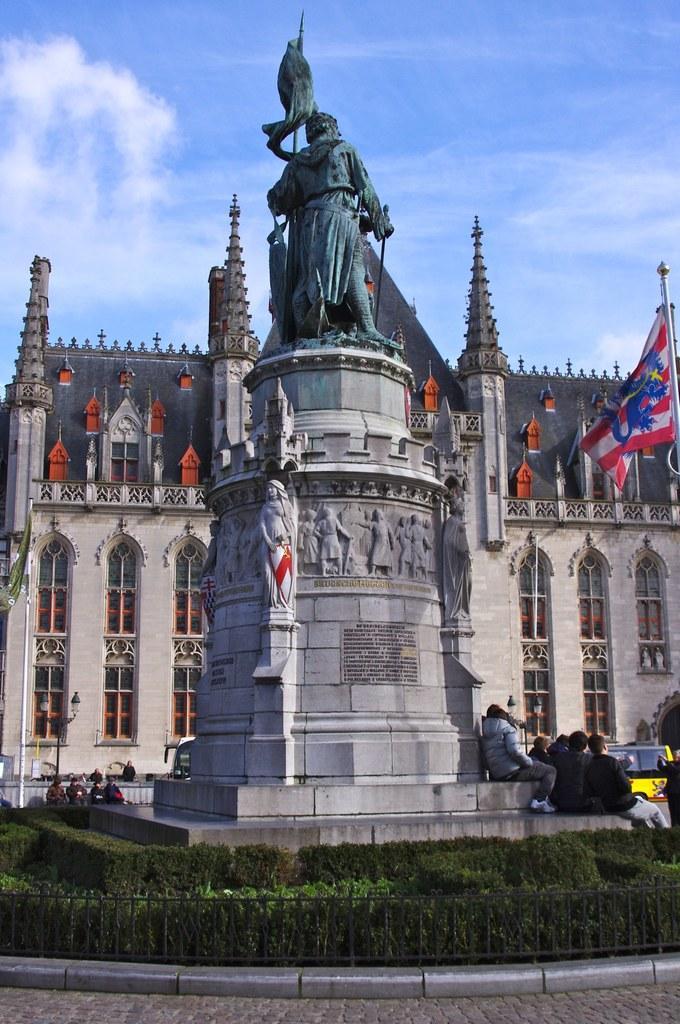Could you give a brief overview of what you see in this image? In front of the picture, we see a monument or a statue of the man standing. At the bottom of the picture, we see plants, shrubs and a railing. We see people sitting beside the monument. Beside them, we see a yellow color vehicle is moving on the road. In the background, we see a building and it looks like a court. On the right side, we see a flag in red, white and blue color. At the top of the picture, we see the sky. 